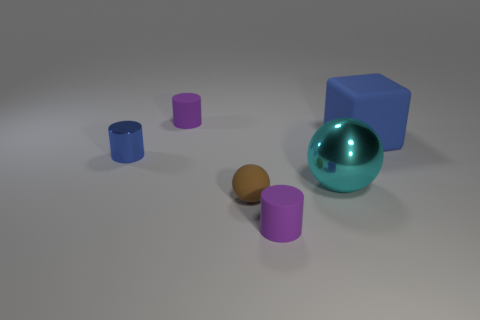What is the texture of the objects on the surface? The objects have a smooth and glossy texture, reflecting the light and exhibiting clear, sharp shadows on the surface, indicating a strong source of light in the scene. What could you infer about the material used for these objects? Given their smooth texture and shine, the objects likely simulate materials like plastic or polished stone, commonly used for geometric demonstration models. 